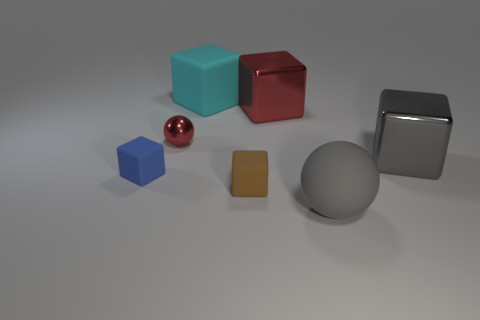There is a cyan rubber object; does it have the same shape as the brown object on the left side of the red metallic block?
Your answer should be very brief. Yes. Are there more big gray rubber things than balls?
Make the answer very short. No. Are there any other things that have the same size as the brown cube?
Make the answer very short. Yes. Does the big gray object in front of the small blue thing have the same shape as the big cyan matte thing?
Your answer should be compact. No. Are there more big gray rubber things on the left side of the gray metallic cube than spheres?
Offer a very short reply. No. There is a small object that is left of the sphere to the left of the big red metallic thing; what color is it?
Provide a short and direct response. Blue. How many large cyan rubber blocks are there?
Make the answer very short. 1. How many big objects are behind the blue rubber block and on the left side of the gray metal block?
Keep it short and to the point. 2. Is there any other thing that has the same shape as the blue matte thing?
Your response must be concise. Yes. There is a matte sphere; is it the same color as the small rubber object that is behind the brown block?
Make the answer very short. No. 